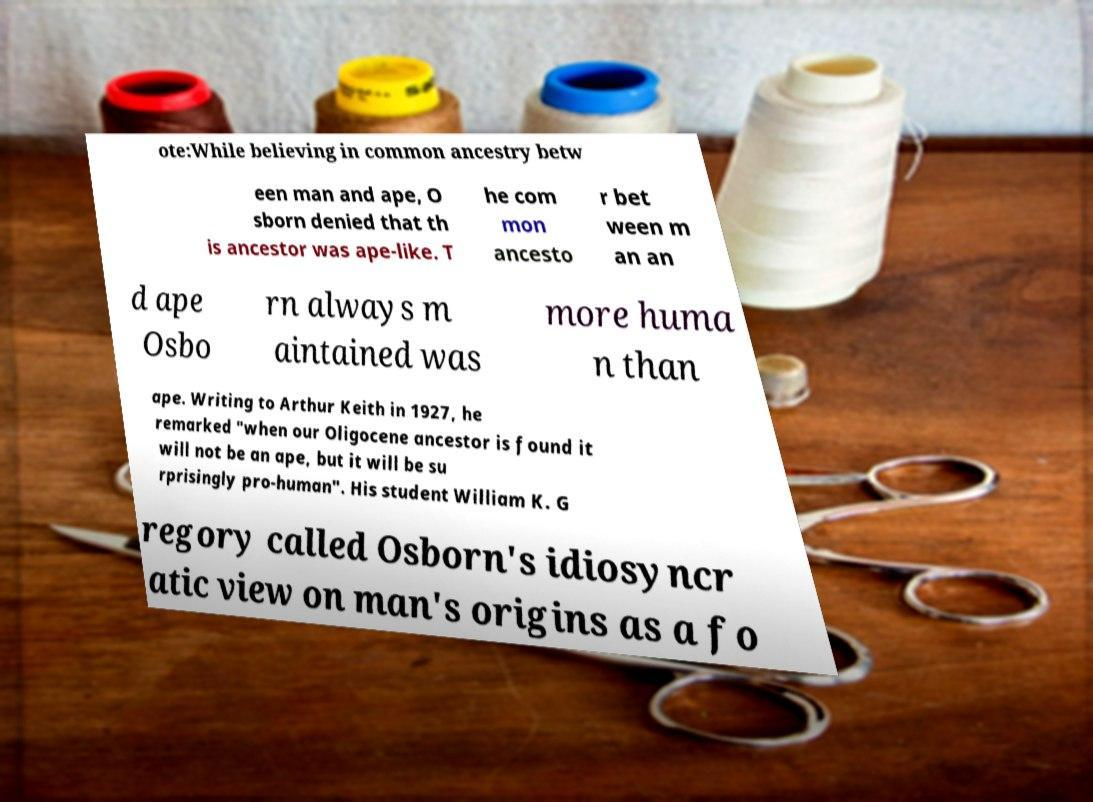For documentation purposes, I need the text within this image transcribed. Could you provide that? ote:While believing in common ancestry betw een man and ape, O sborn denied that th is ancestor was ape-like. T he com mon ancesto r bet ween m an an d ape Osbo rn always m aintained was more huma n than ape. Writing to Arthur Keith in 1927, he remarked "when our Oligocene ancestor is found it will not be an ape, but it will be su rprisingly pro-human". His student William K. G regory called Osborn's idiosyncr atic view on man's origins as a fo 